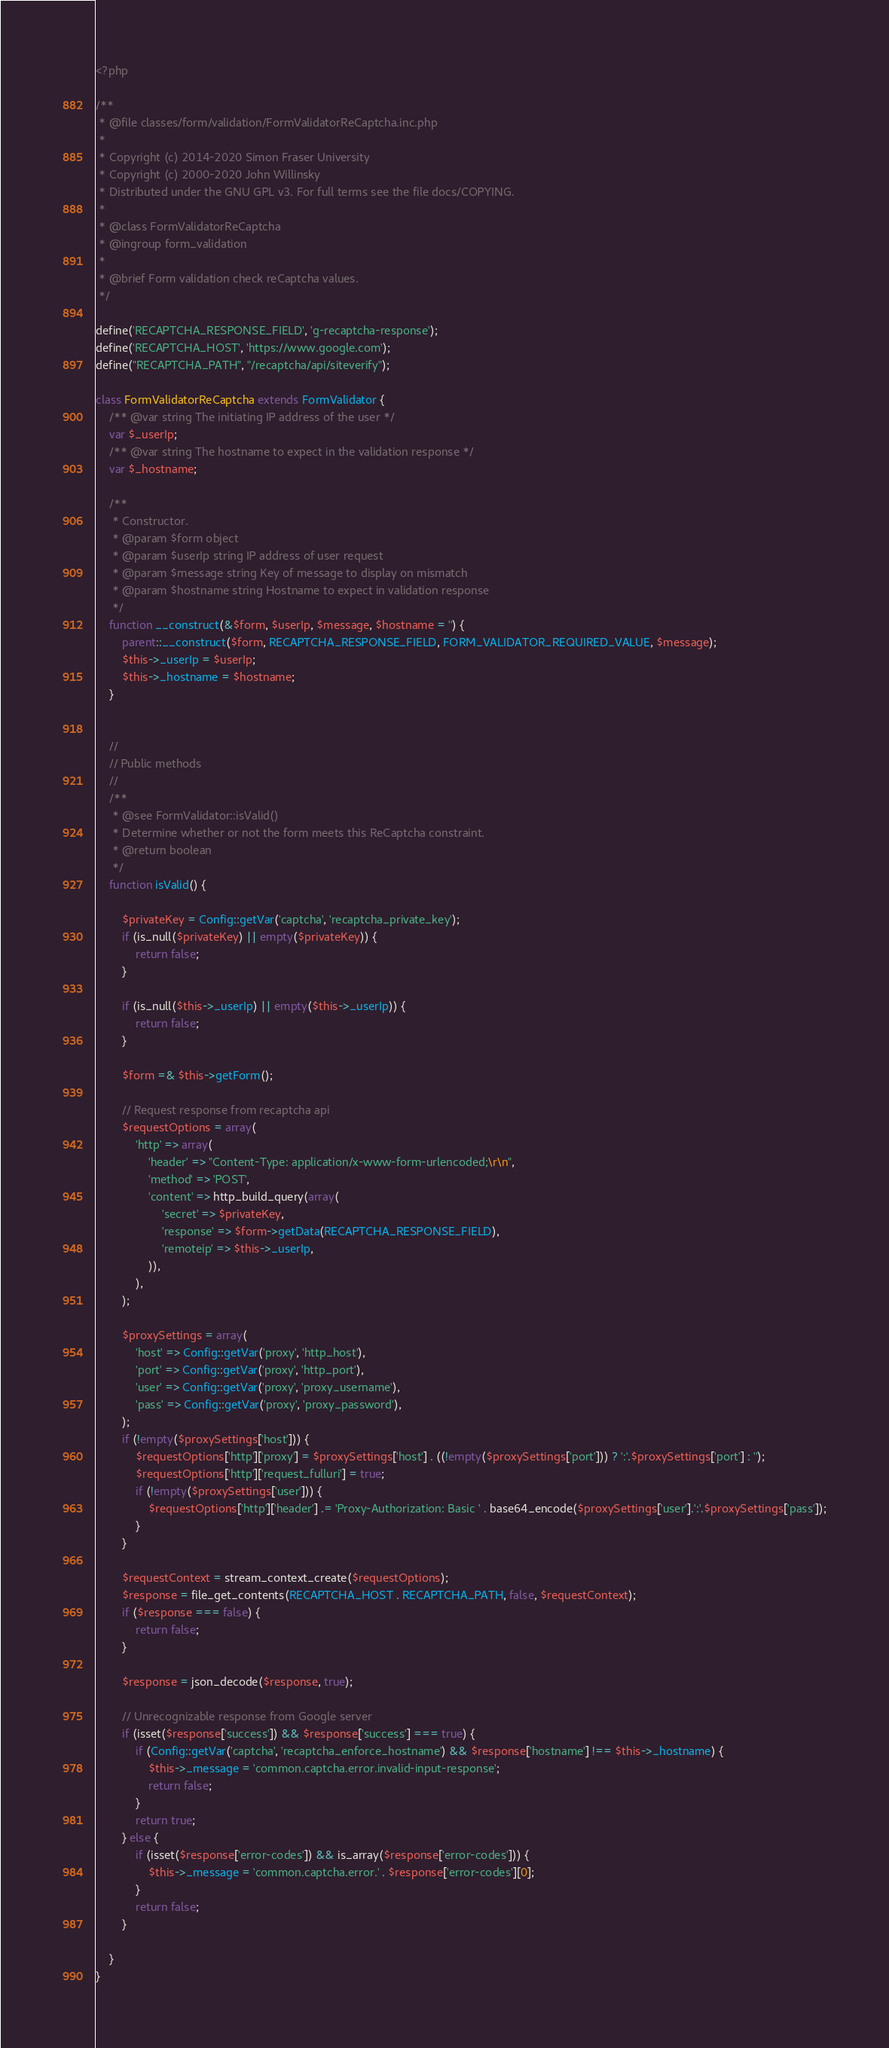Convert code to text. <code><loc_0><loc_0><loc_500><loc_500><_PHP_><?php

/**
 * @file classes/form/validation/FormValidatorReCaptcha.inc.php
 *
 * Copyright (c) 2014-2020 Simon Fraser University
 * Copyright (c) 2000-2020 John Willinsky
 * Distributed under the GNU GPL v3. For full terms see the file docs/COPYING.
 *
 * @class FormValidatorReCaptcha
 * @ingroup form_validation
 *
 * @brief Form validation check reCaptcha values.
 */

define('RECAPTCHA_RESPONSE_FIELD', 'g-recaptcha-response');
define('RECAPTCHA_HOST', 'https://www.google.com');
define("RECAPTCHA_PATH", "/recaptcha/api/siteverify");

class FormValidatorReCaptcha extends FormValidator {
	/** @var string The initiating IP address of the user */
	var $_userIp;
	/** @var string The hostname to expect in the validation response */
	var $_hostname;

	/**
	 * Constructor.
	 * @param $form object
	 * @param $userIp string IP address of user request
	 * @param $message string Key of message to display on mismatch
	 * @param $hostname string Hostname to expect in validation response
	 */
	function __construct(&$form, $userIp, $message, $hostname = '') {
		parent::__construct($form, RECAPTCHA_RESPONSE_FIELD, FORM_VALIDATOR_REQUIRED_VALUE, $message);
		$this->_userIp = $userIp;
		$this->_hostname = $hostname;
	}


	//
	// Public methods
	//
	/**
	 * @see FormValidator::isValid()
	 * Determine whether or not the form meets this ReCaptcha constraint.
	 * @return boolean
	 */
	function isValid() {

		$privateKey = Config::getVar('captcha', 'recaptcha_private_key');
		if (is_null($privateKey) || empty($privateKey)) {
			return false;
		}

		if (is_null($this->_userIp) || empty($this->_userIp)) {
			return false;
		}

		$form =& $this->getForm();

		// Request response from recaptcha api
		$requestOptions = array(
			'http' => array(
				'header' => "Content-Type: application/x-www-form-urlencoded;\r\n",
				'method' => 'POST',
				'content' => http_build_query(array(
					'secret' => $privateKey,
					'response' => $form->getData(RECAPTCHA_RESPONSE_FIELD),
					'remoteip' => $this->_userIp,
				)),
			),
		);

		$proxySettings = array(
			'host' => Config::getVar('proxy', 'http_host'),
			'port' => Config::getVar('proxy', 'http_port'),
			'user' => Config::getVar('proxy', 'proxy_username'),
			'pass' => Config::getVar('proxy', 'proxy_password'),
		);
		if (!empty($proxySettings['host'])) {
			$requestOptions['http']['proxy'] = $proxySettings['host'] . ((!empty($proxySettings['port'])) ? ':'.$proxySettings['port'] : '');
			$requestOptions['http']['request_fulluri'] = true;
			if (!empty($proxySettings['user'])) {
				$requestOptions['http']['header'] .= 'Proxy-Authorization: Basic ' . base64_encode($proxySettings['user'].':'.$proxySettings['pass']);
			}
		}

		$requestContext = stream_context_create($requestOptions);
		$response = file_get_contents(RECAPTCHA_HOST . RECAPTCHA_PATH, false, $requestContext);
		if ($response === false) {
			return false;
		}

		$response = json_decode($response, true);

		// Unrecognizable response from Google server
		if (isset($response['success']) && $response['success'] === true) {
			if (Config::getVar('captcha', 'recaptcha_enforce_hostname') && $response['hostname'] !== $this->_hostname) {
				$this->_message = 'common.captcha.error.invalid-input-response';
				return false;
			}
			return true;
		} else {
			if (isset($response['error-codes']) && is_array($response['error-codes'])) {
				$this->_message = 'common.captcha.error.' . $response['error-codes'][0];
			}
			return false;
		}

	}
}



</code> 